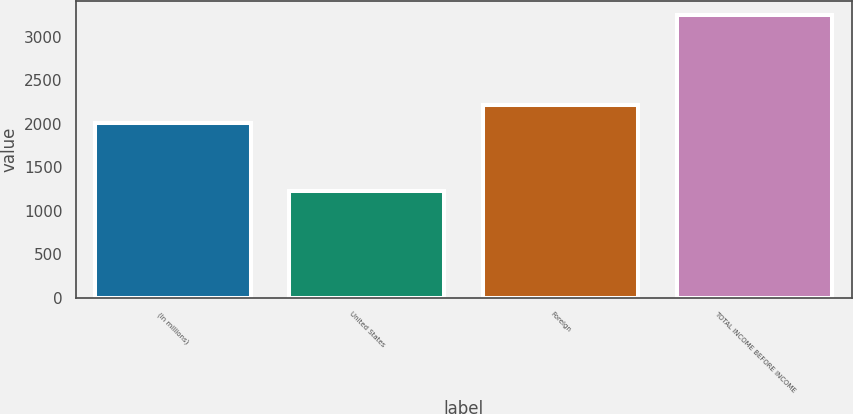Convert chart. <chart><loc_0><loc_0><loc_500><loc_500><bar_chart><fcel>(In millions)<fcel>United States<fcel>Foreign<fcel>TOTAL INCOME BEFORE INCOME<nl><fcel>2013<fcel>1231<fcel>2215.5<fcel>3256<nl></chart> 